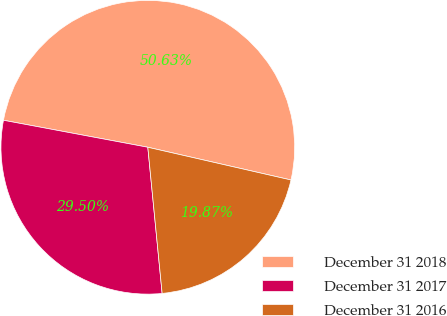Convert chart to OTSL. <chart><loc_0><loc_0><loc_500><loc_500><pie_chart><fcel>December 31 2018<fcel>December 31 2017<fcel>December 31 2016<nl><fcel>50.64%<fcel>29.5%<fcel>19.87%<nl></chart> 